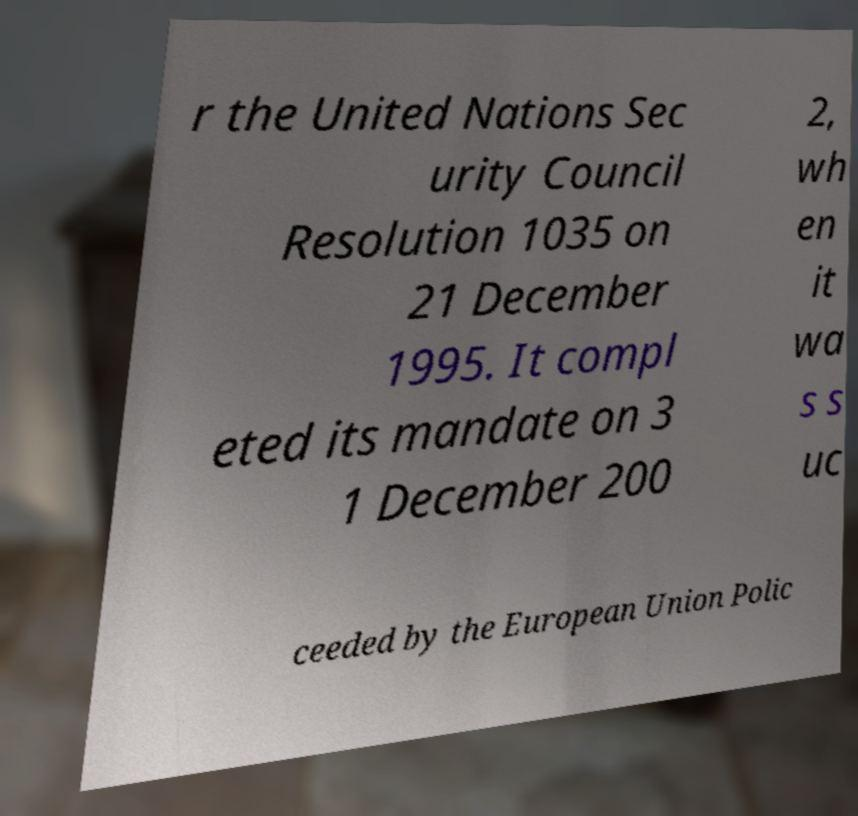Please read and relay the text visible in this image. What does it say? r the United Nations Sec urity Council Resolution 1035 on 21 December 1995. It compl eted its mandate on 3 1 December 200 2, wh en it wa s s uc ceeded by the European Union Polic 